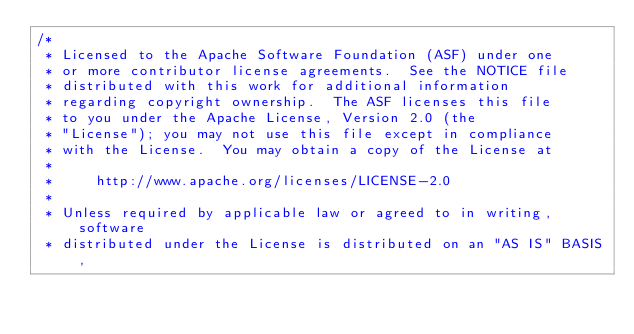Convert code to text. <code><loc_0><loc_0><loc_500><loc_500><_Java_>/*
 * Licensed to the Apache Software Foundation (ASF) under one
 * or more contributor license agreements.  See the NOTICE file
 * distributed with this work for additional information
 * regarding copyright ownership.  The ASF licenses this file
 * to you under the Apache License, Version 2.0 (the
 * "License"); you may not use this file except in compliance
 * with the License.  You may obtain a copy of the License at
 *
 *     http://www.apache.org/licenses/LICENSE-2.0
 *
 * Unless required by applicable law or agreed to in writing, software
 * distributed under the License is distributed on an "AS IS" BASIS,</code> 